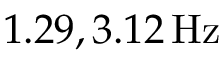<formula> <loc_0><loc_0><loc_500><loc_500>1 . 2 9 , 3 . 1 2 \, H z</formula> 